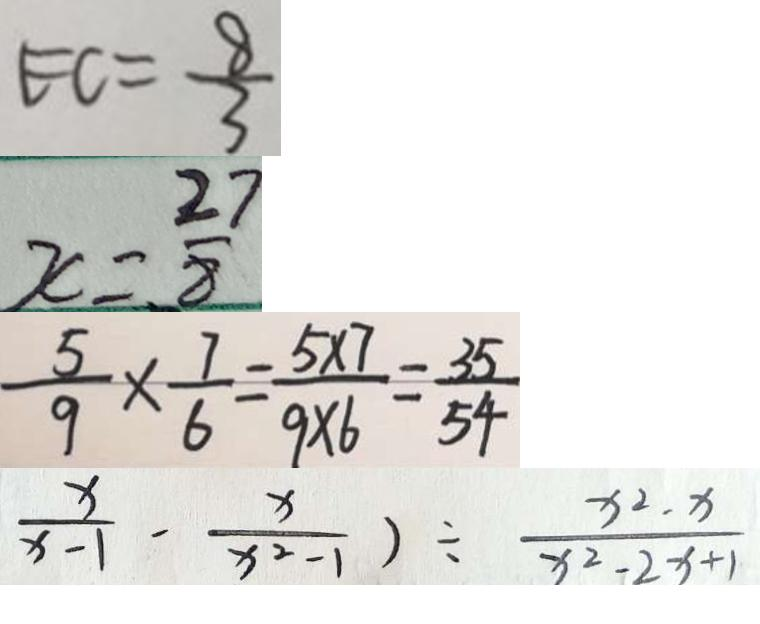<formula> <loc_0><loc_0><loc_500><loc_500>E C = \frac { 8 } { 3 } 
 x = \frac { 2 7 } { 8 } 
 \frac { 5 } { 9 } \times \frac { 7 } { 6 } = \frac { 5 \times 7 } { 9 \times 6 } = \frac { 3 5 } { 5 4 } 
 \frac { x } { x - 1 } - \frac { x } { x ^ { 2 } - 1 } ) \div \frac { x ^ { 2 } - x } { x ^ { 2 } - 2 x + 1 }</formula> 